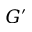<formula> <loc_0><loc_0><loc_500><loc_500>G ^ { \prime }</formula> 